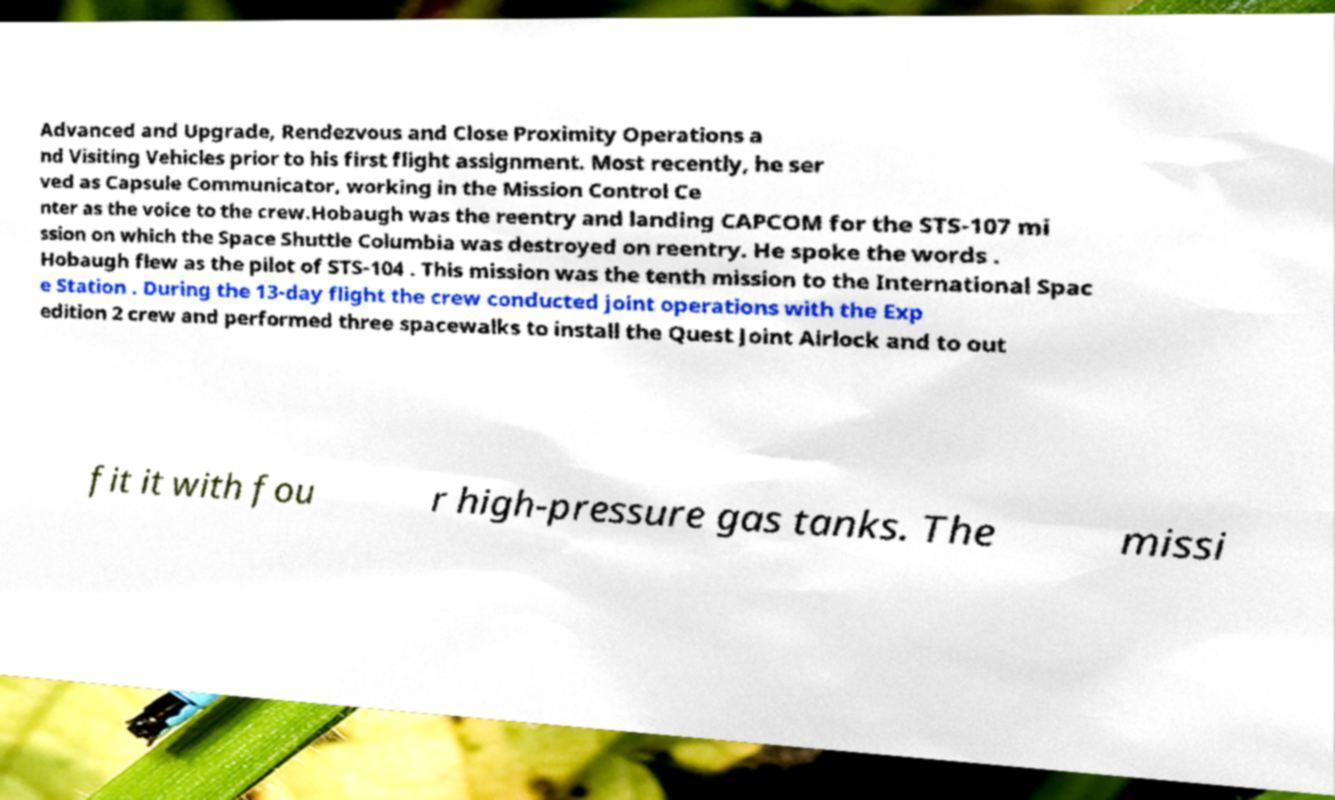Can you read and provide the text displayed in the image?This photo seems to have some interesting text. Can you extract and type it out for me? Advanced and Upgrade, Rendezvous and Close Proximity Operations a nd Visiting Vehicles prior to his first flight assignment. Most recently, he ser ved as Capsule Communicator, working in the Mission Control Ce nter as the voice to the crew.Hobaugh was the reentry and landing CAPCOM for the STS-107 mi ssion on which the Space Shuttle Columbia was destroyed on reentry. He spoke the words . Hobaugh flew as the pilot of STS-104 . This mission was the tenth mission to the International Spac e Station . During the 13-day flight the crew conducted joint operations with the Exp edition 2 crew and performed three spacewalks to install the Quest Joint Airlock and to out fit it with fou r high-pressure gas tanks. The missi 